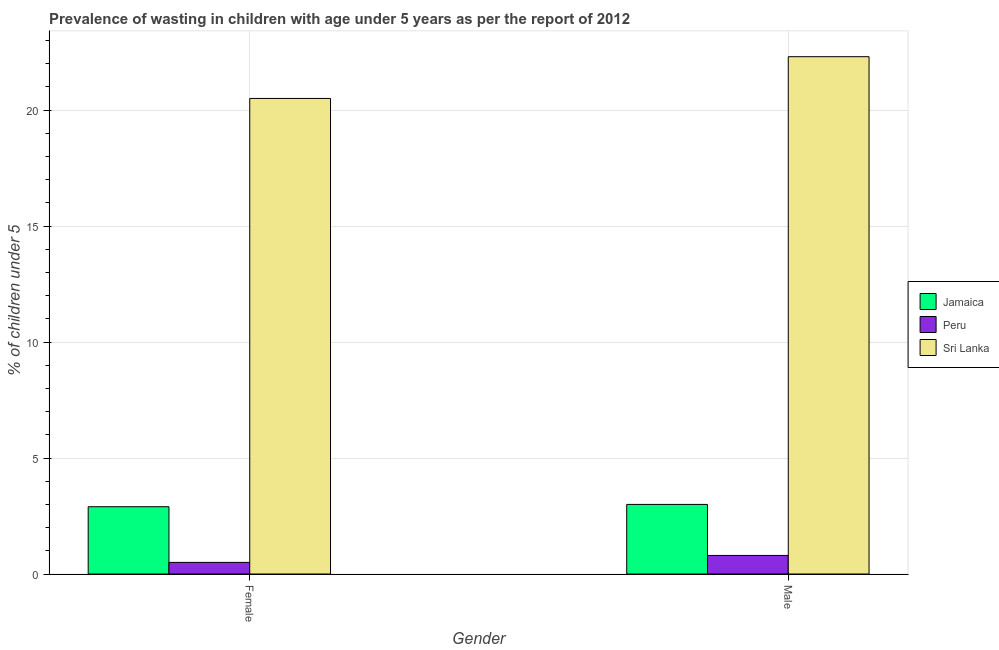How many groups of bars are there?
Offer a terse response. 2. Are the number of bars per tick equal to the number of legend labels?
Give a very brief answer. Yes. Are the number of bars on each tick of the X-axis equal?
Give a very brief answer. Yes. How many bars are there on the 1st tick from the right?
Keep it short and to the point. 3. Across all countries, what is the minimum percentage of undernourished male children?
Give a very brief answer. 0.8. In which country was the percentage of undernourished female children maximum?
Your answer should be compact. Sri Lanka. What is the total percentage of undernourished male children in the graph?
Offer a terse response. 26.1. What is the difference between the percentage of undernourished female children in Jamaica and that in Peru?
Your answer should be compact. 2.4. What is the difference between the percentage of undernourished male children in Jamaica and the percentage of undernourished female children in Peru?
Give a very brief answer. 2.5. What is the average percentage of undernourished female children per country?
Offer a terse response. 7.97. What is the difference between the percentage of undernourished female children and percentage of undernourished male children in Jamaica?
Make the answer very short. -0.1. In how many countries, is the percentage of undernourished male children greater than 17 %?
Your answer should be compact. 1. What is the ratio of the percentage of undernourished male children in Peru to that in Jamaica?
Make the answer very short. 0.27. Is the percentage of undernourished female children in Peru less than that in Jamaica?
Your answer should be compact. Yes. What does the 1st bar from the left in Male represents?
Offer a very short reply. Jamaica. What does the 2nd bar from the right in Male represents?
Offer a terse response. Peru. What is the difference between two consecutive major ticks on the Y-axis?
Your answer should be very brief. 5. Are the values on the major ticks of Y-axis written in scientific E-notation?
Offer a very short reply. No. Where does the legend appear in the graph?
Offer a very short reply. Center right. How many legend labels are there?
Provide a short and direct response. 3. How are the legend labels stacked?
Provide a short and direct response. Vertical. What is the title of the graph?
Your response must be concise. Prevalence of wasting in children with age under 5 years as per the report of 2012. What is the label or title of the Y-axis?
Offer a terse response.  % of children under 5. What is the  % of children under 5 of Jamaica in Female?
Your answer should be compact. 2.9. What is the  % of children under 5 in Peru in Male?
Keep it short and to the point. 0.8. What is the  % of children under 5 of Sri Lanka in Male?
Make the answer very short. 22.3. Across all Gender, what is the maximum  % of children under 5 in Peru?
Provide a short and direct response. 0.8. Across all Gender, what is the maximum  % of children under 5 of Sri Lanka?
Ensure brevity in your answer.  22.3. Across all Gender, what is the minimum  % of children under 5 in Jamaica?
Give a very brief answer. 2.9. What is the total  % of children under 5 of Peru in the graph?
Offer a very short reply. 1.3. What is the total  % of children under 5 in Sri Lanka in the graph?
Provide a succinct answer. 42.8. What is the difference between the  % of children under 5 in Peru in Female and that in Male?
Provide a succinct answer. -0.3. What is the difference between the  % of children under 5 of Sri Lanka in Female and that in Male?
Give a very brief answer. -1.8. What is the difference between the  % of children under 5 of Jamaica in Female and the  % of children under 5 of Sri Lanka in Male?
Offer a very short reply. -19.4. What is the difference between the  % of children under 5 of Peru in Female and the  % of children under 5 of Sri Lanka in Male?
Keep it short and to the point. -21.8. What is the average  % of children under 5 of Jamaica per Gender?
Your answer should be compact. 2.95. What is the average  % of children under 5 in Peru per Gender?
Ensure brevity in your answer.  0.65. What is the average  % of children under 5 in Sri Lanka per Gender?
Offer a very short reply. 21.4. What is the difference between the  % of children under 5 of Jamaica and  % of children under 5 of Sri Lanka in Female?
Make the answer very short. -17.6. What is the difference between the  % of children under 5 in Peru and  % of children under 5 in Sri Lanka in Female?
Your answer should be compact. -20. What is the difference between the  % of children under 5 of Jamaica and  % of children under 5 of Sri Lanka in Male?
Provide a succinct answer. -19.3. What is the difference between the  % of children under 5 of Peru and  % of children under 5 of Sri Lanka in Male?
Ensure brevity in your answer.  -21.5. What is the ratio of the  % of children under 5 in Jamaica in Female to that in Male?
Your response must be concise. 0.97. What is the ratio of the  % of children under 5 in Peru in Female to that in Male?
Give a very brief answer. 0.62. What is the ratio of the  % of children under 5 of Sri Lanka in Female to that in Male?
Your answer should be very brief. 0.92. What is the difference between the highest and the second highest  % of children under 5 of Sri Lanka?
Offer a very short reply. 1.8. What is the difference between the highest and the lowest  % of children under 5 in Jamaica?
Provide a succinct answer. 0.1. What is the difference between the highest and the lowest  % of children under 5 of Peru?
Provide a short and direct response. 0.3. What is the difference between the highest and the lowest  % of children under 5 in Sri Lanka?
Provide a succinct answer. 1.8. 